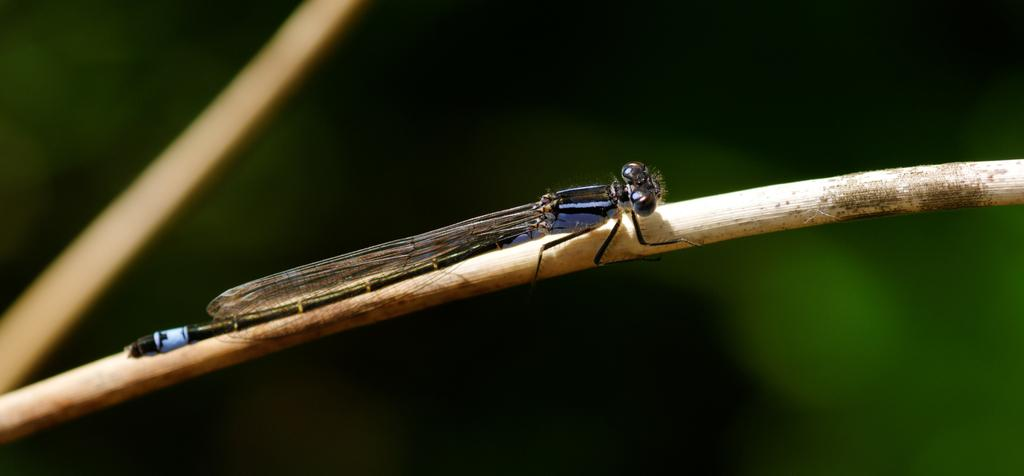What type of creature can be seen in the image? There is an insect in the image. Can you describe the background of the image? The background of the image is blurry. What subject is the insect teaching in the image? There is no indication in the image that the insect is teaching any subject, as insects do not have the ability to teach. 